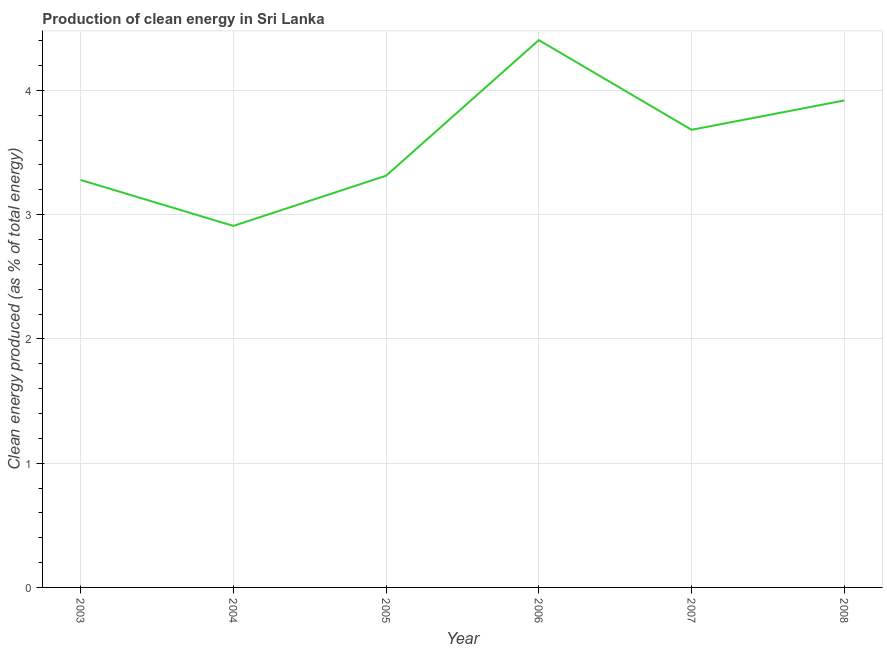What is the production of clean energy in 2003?
Your answer should be very brief. 3.28. Across all years, what is the maximum production of clean energy?
Provide a succinct answer. 4.4. Across all years, what is the minimum production of clean energy?
Offer a very short reply. 2.91. In which year was the production of clean energy maximum?
Offer a terse response. 2006. What is the sum of the production of clean energy?
Provide a short and direct response. 21.5. What is the difference between the production of clean energy in 2005 and 2007?
Offer a very short reply. -0.37. What is the average production of clean energy per year?
Keep it short and to the point. 3.58. What is the median production of clean energy?
Make the answer very short. 3.5. What is the ratio of the production of clean energy in 2005 to that in 2008?
Give a very brief answer. 0.85. Is the production of clean energy in 2006 less than that in 2008?
Offer a terse response. No. What is the difference between the highest and the second highest production of clean energy?
Offer a very short reply. 0.49. What is the difference between the highest and the lowest production of clean energy?
Offer a very short reply. 1.49. In how many years, is the production of clean energy greater than the average production of clean energy taken over all years?
Your answer should be compact. 3. How many lines are there?
Keep it short and to the point. 1. How many years are there in the graph?
Offer a very short reply. 6. Are the values on the major ticks of Y-axis written in scientific E-notation?
Make the answer very short. No. Does the graph contain grids?
Provide a short and direct response. Yes. What is the title of the graph?
Keep it short and to the point. Production of clean energy in Sri Lanka. What is the label or title of the Y-axis?
Offer a very short reply. Clean energy produced (as % of total energy). What is the Clean energy produced (as % of total energy) in 2003?
Your answer should be very brief. 3.28. What is the Clean energy produced (as % of total energy) of 2004?
Offer a terse response. 2.91. What is the Clean energy produced (as % of total energy) in 2005?
Provide a short and direct response. 3.31. What is the Clean energy produced (as % of total energy) of 2006?
Provide a succinct answer. 4.4. What is the Clean energy produced (as % of total energy) in 2007?
Your answer should be compact. 3.68. What is the Clean energy produced (as % of total energy) in 2008?
Offer a terse response. 3.92. What is the difference between the Clean energy produced (as % of total energy) in 2003 and 2004?
Provide a short and direct response. 0.37. What is the difference between the Clean energy produced (as % of total energy) in 2003 and 2005?
Provide a succinct answer. -0.03. What is the difference between the Clean energy produced (as % of total energy) in 2003 and 2006?
Ensure brevity in your answer.  -1.13. What is the difference between the Clean energy produced (as % of total energy) in 2003 and 2007?
Your answer should be compact. -0.4. What is the difference between the Clean energy produced (as % of total energy) in 2003 and 2008?
Provide a short and direct response. -0.64. What is the difference between the Clean energy produced (as % of total energy) in 2004 and 2005?
Make the answer very short. -0.4. What is the difference between the Clean energy produced (as % of total energy) in 2004 and 2006?
Provide a short and direct response. -1.49. What is the difference between the Clean energy produced (as % of total energy) in 2004 and 2007?
Ensure brevity in your answer.  -0.77. What is the difference between the Clean energy produced (as % of total energy) in 2004 and 2008?
Offer a terse response. -1.01. What is the difference between the Clean energy produced (as % of total energy) in 2005 and 2006?
Offer a terse response. -1.09. What is the difference between the Clean energy produced (as % of total energy) in 2005 and 2007?
Your answer should be very brief. -0.37. What is the difference between the Clean energy produced (as % of total energy) in 2005 and 2008?
Give a very brief answer. -0.61. What is the difference between the Clean energy produced (as % of total energy) in 2006 and 2007?
Your answer should be compact. 0.72. What is the difference between the Clean energy produced (as % of total energy) in 2006 and 2008?
Offer a very short reply. 0.49. What is the difference between the Clean energy produced (as % of total energy) in 2007 and 2008?
Provide a succinct answer. -0.24. What is the ratio of the Clean energy produced (as % of total energy) in 2003 to that in 2004?
Offer a terse response. 1.13. What is the ratio of the Clean energy produced (as % of total energy) in 2003 to that in 2006?
Provide a succinct answer. 0.74. What is the ratio of the Clean energy produced (as % of total energy) in 2003 to that in 2007?
Keep it short and to the point. 0.89. What is the ratio of the Clean energy produced (as % of total energy) in 2003 to that in 2008?
Give a very brief answer. 0.84. What is the ratio of the Clean energy produced (as % of total energy) in 2004 to that in 2005?
Give a very brief answer. 0.88. What is the ratio of the Clean energy produced (as % of total energy) in 2004 to that in 2006?
Provide a short and direct response. 0.66. What is the ratio of the Clean energy produced (as % of total energy) in 2004 to that in 2007?
Give a very brief answer. 0.79. What is the ratio of the Clean energy produced (as % of total energy) in 2004 to that in 2008?
Provide a short and direct response. 0.74. What is the ratio of the Clean energy produced (as % of total energy) in 2005 to that in 2006?
Offer a terse response. 0.75. What is the ratio of the Clean energy produced (as % of total energy) in 2005 to that in 2007?
Provide a succinct answer. 0.9. What is the ratio of the Clean energy produced (as % of total energy) in 2005 to that in 2008?
Give a very brief answer. 0.84. What is the ratio of the Clean energy produced (as % of total energy) in 2006 to that in 2007?
Your answer should be compact. 1.2. What is the ratio of the Clean energy produced (as % of total energy) in 2006 to that in 2008?
Make the answer very short. 1.12. 